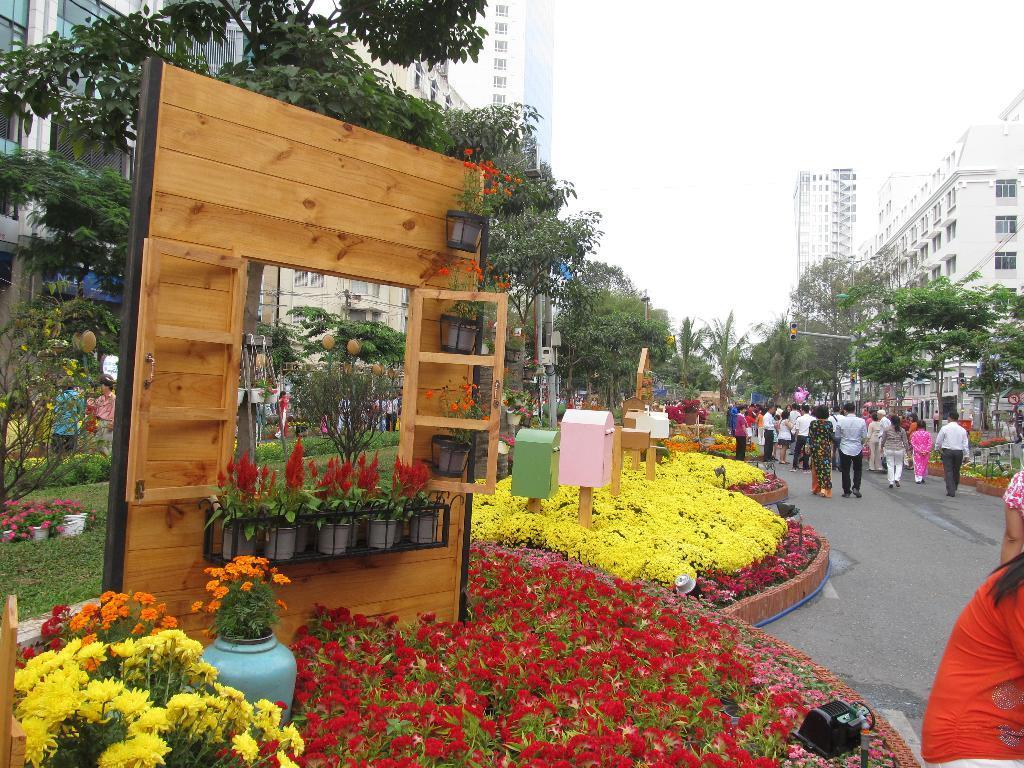How would you summarize this image in a sentence or two? In the picture we can see some flowers, flower pots, plants and in the background of the picture there are some trees, buildings and clear sky. 